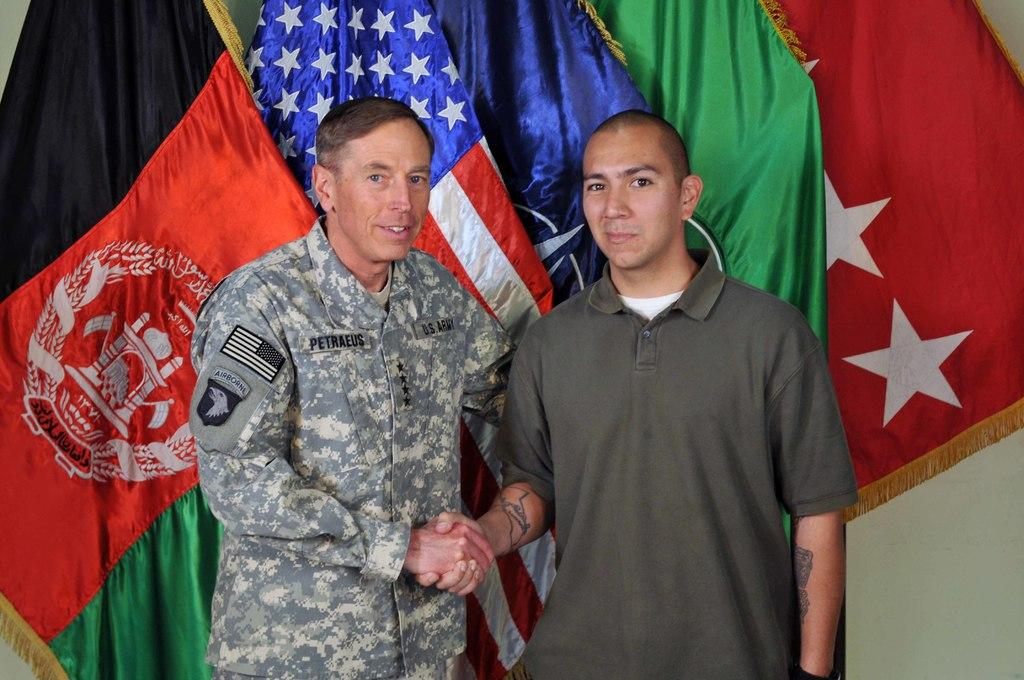<image>
Relay a brief, clear account of the picture shown. Soldier wearing an outfit that says PETRAEUS shaking hands with another man. 